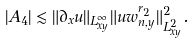<formula> <loc_0><loc_0><loc_500><loc_500>| A _ { 4 } | \lesssim \| \partial _ { x } u \| _ { L ^ { \infty } _ { x y } } \| u w _ { n , y } ^ { r _ { 2 } } \| _ { L ^ { 2 } _ { x y } } ^ { 2 } .</formula> 